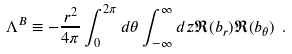<formula> <loc_0><loc_0><loc_500><loc_500>\Lambda ^ { B } \equiv - \frac { r ^ { 2 } } { 4 \pi } \int _ { 0 } ^ { 2 \pi } d \theta \int _ { - \infty } ^ { \infty } d z \Re ( b _ { r } ) \Re ( b _ { \theta } ) \ .</formula> 